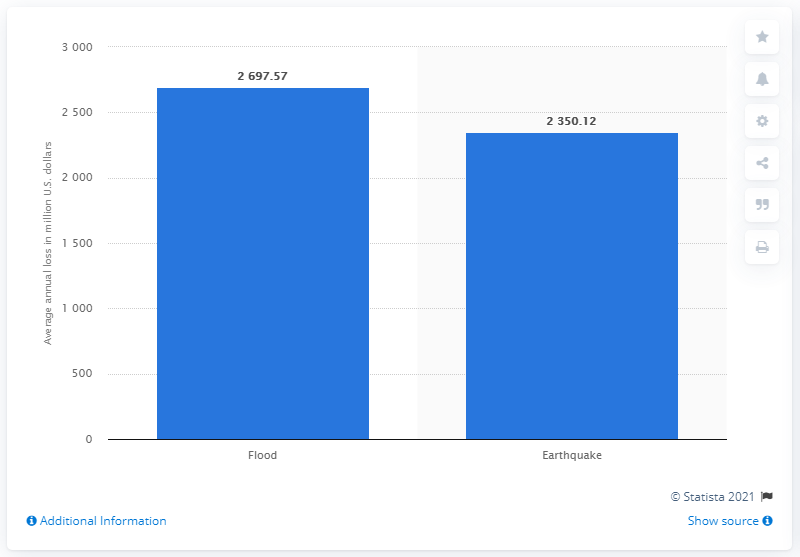List a handful of essential elements in this visual. As of 2015, the estimated annual loss due to flooding in Germany was approximately 2697.57... 